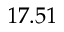<formula> <loc_0><loc_0><loc_500><loc_500>1 7 . 5 1</formula> 